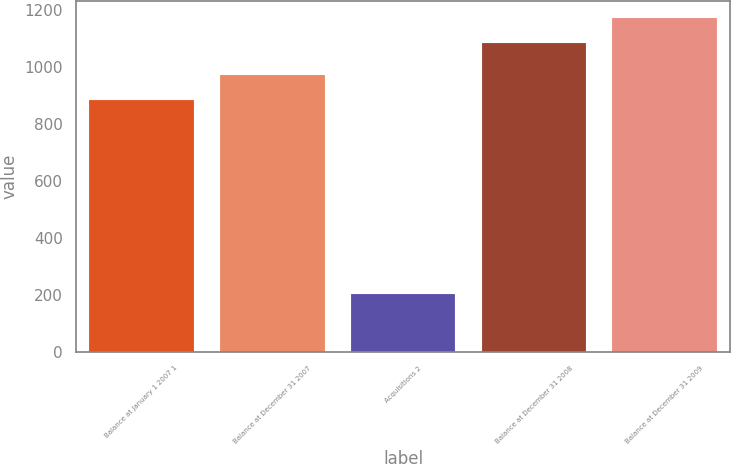<chart> <loc_0><loc_0><loc_500><loc_500><bar_chart><fcel>Balance at January 1 2007 1<fcel>Balance at December 31 2007<fcel>Acquisitions 2<fcel>Balance at December 31 2008<fcel>Balance at December 31 2009<nl><fcel>883<fcel>973.1<fcel>201<fcel>1084<fcel>1174.1<nl></chart> 